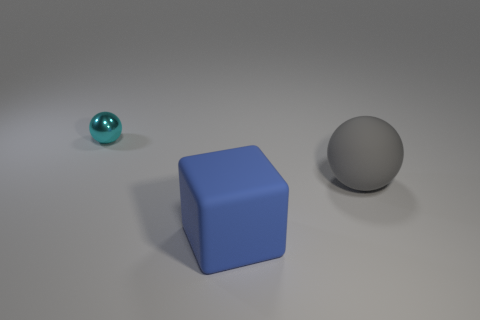Add 3 small cyan matte spheres. How many objects exist? 6 Add 1 tiny cyan shiny balls. How many tiny cyan shiny balls exist? 2 Subtract all cyan balls. How many balls are left? 1 Subtract 0 red cylinders. How many objects are left? 3 Subtract all blocks. How many objects are left? 2 Subtract 2 balls. How many balls are left? 0 Subtract all purple spheres. Subtract all cyan cylinders. How many spheres are left? 2 Subtract all blue cylinders. How many cyan balls are left? 1 Subtract all small objects. Subtract all cyan spheres. How many objects are left? 1 Add 2 blue things. How many blue things are left? 3 